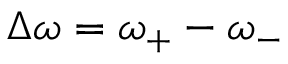<formula> <loc_0><loc_0><loc_500><loc_500>\Delta \omega = \omega _ { + } - \omega _ { - }</formula> 